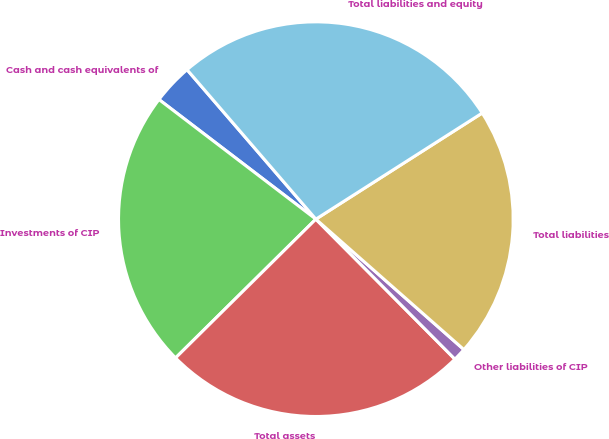Convert chart to OTSL. <chart><loc_0><loc_0><loc_500><loc_500><pie_chart><fcel>Cash and cash equivalents of<fcel>Investments of CIP<fcel>Total assets<fcel>Other liabilities of CIP<fcel>Total liabilities<fcel>Total liabilities and equity<nl><fcel>3.31%<fcel>22.78%<fcel>25.03%<fcel>1.06%<fcel>20.53%<fcel>27.28%<nl></chart> 